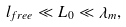Convert formula to latex. <formula><loc_0><loc_0><loc_500><loc_500>l _ { f r e e } \ll L _ { 0 } \ll \lambda _ { m } ,</formula> 